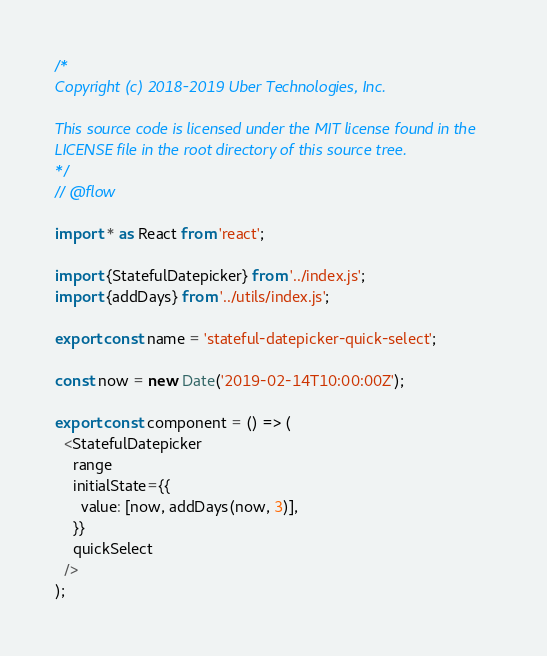<code> <loc_0><loc_0><loc_500><loc_500><_JavaScript_>/*
Copyright (c) 2018-2019 Uber Technologies, Inc.

This source code is licensed under the MIT license found in the
LICENSE file in the root directory of this source tree.
*/
// @flow

import * as React from 'react';

import {StatefulDatepicker} from '../index.js';
import {addDays} from '../utils/index.js';

export const name = 'stateful-datepicker-quick-select';

const now = new Date('2019-02-14T10:00:00Z');

export const component = () => (
  <StatefulDatepicker
    range
    initialState={{
      value: [now, addDays(now, 3)],
    }}
    quickSelect
  />
);
</code> 